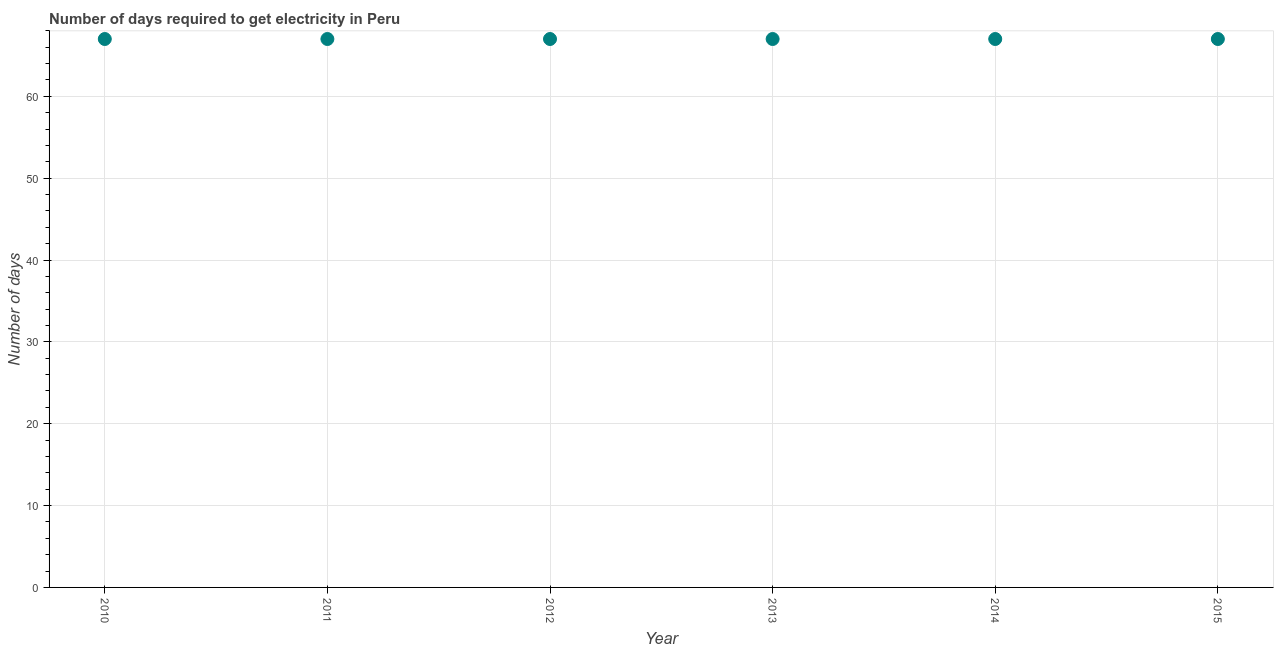What is the time to get electricity in 2012?
Provide a succinct answer. 67. Across all years, what is the maximum time to get electricity?
Offer a very short reply. 67. Across all years, what is the minimum time to get electricity?
Offer a terse response. 67. In which year was the time to get electricity minimum?
Provide a succinct answer. 2010. What is the sum of the time to get electricity?
Your response must be concise. 402. Do a majority of the years between 2012 and 2015 (inclusive) have time to get electricity greater than 48 ?
Your answer should be very brief. Yes. Is the time to get electricity in 2013 less than that in 2015?
Provide a succinct answer. No. What is the difference between the highest and the lowest time to get electricity?
Keep it short and to the point. 0. Does the time to get electricity monotonically increase over the years?
Offer a terse response. No. How many dotlines are there?
Make the answer very short. 1. How many years are there in the graph?
Give a very brief answer. 6. What is the difference between two consecutive major ticks on the Y-axis?
Offer a terse response. 10. Are the values on the major ticks of Y-axis written in scientific E-notation?
Your answer should be compact. No. Does the graph contain grids?
Provide a succinct answer. Yes. What is the title of the graph?
Keep it short and to the point. Number of days required to get electricity in Peru. What is the label or title of the Y-axis?
Your answer should be very brief. Number of days. What is the Number of days in 2011?
Your answer should be compact. 67. What is the Number of days in 2015?
Keep it short and to the point. 67. What is the difference between the Number of days in 2010 and 2012?
Offer a terse response. 0. What is the difference between the Number of days in 2010 and 2013?
Offer a very short reply. 0. What is the difference between the Number of days in 2010 and 2015?
Your answer should be compact. 0. What is the difference between the Number of days in 2011 and 2012?
Provide a succinct answer. 0. What is the difference between the Number of days in 2012 and 2013?
Make the answer very short. 0. What is the difference between the Number of days in 2012 and 2014?
Keep it short and to the point. 0. What is the difference between the Number of days in 2012 and 2015?
Give a very brief answer. 0. What is the difference between the Number of days in 2013 and 2014?
Provide a short and direct response. 0. What is the difference between the Number of days in 2014 and 2015?
Provide a succinct answer. 0. What is the ratio of the Number of days in 2010 to that in 2012?
Provide a succinct answer. 1. What is the ratio of the Number of days in 2010 to that in 2013?
Keep it short and to the point. 1. What is the ratio of the Number of days in 2011 to that in 2013?
Your response must be concise. 1. What is the ratio of the Number of days in 2011 to that in 2015?
Provide a short and direct response. 1. What is the ratio of the Number of days in 2013 to that in 2015?
Make the answer very short. 1. What is the ratio of the Number of days in 2014 to that in 2015?
Offer a terse response. 1. 